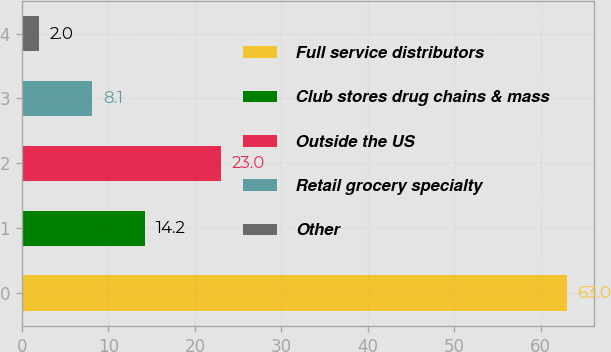Convert chart to OTSL. <chart><loc_0><loc_0><loc_500><loc_500><bar_chart><fcel>Full service distributors<fcel>Club stores drug chains & mass<fcel>Outside the US<fcel>Retail grocery specialty<fcel>Other<nl><fcel>63<fcel>14.2<fcel>23<fcel>8.1<fcel>2<nl></chart> 